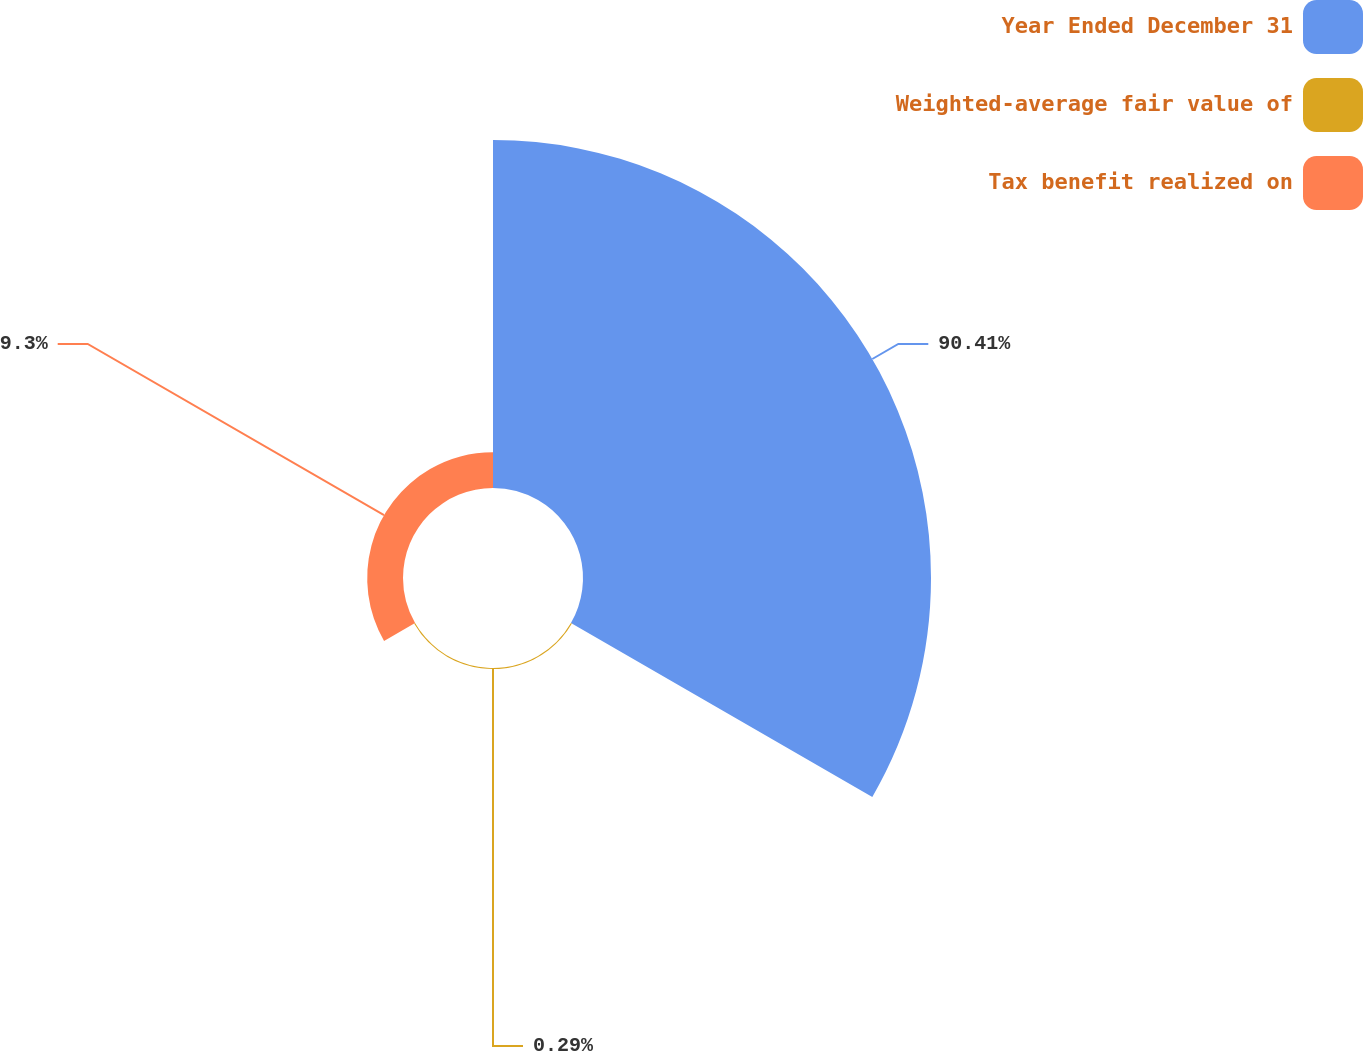Convert chart to OTSL. <chart><loc_0><loc_0><loc_500><loc_500><pie_chart><fcel>Year Ended December 31<fcel>Weighted-average fair value of<fcel>Tax benefit realized on<nl><fcel>90.41%<fcel>0.29%<fcel>9.3%<nl></chart> 